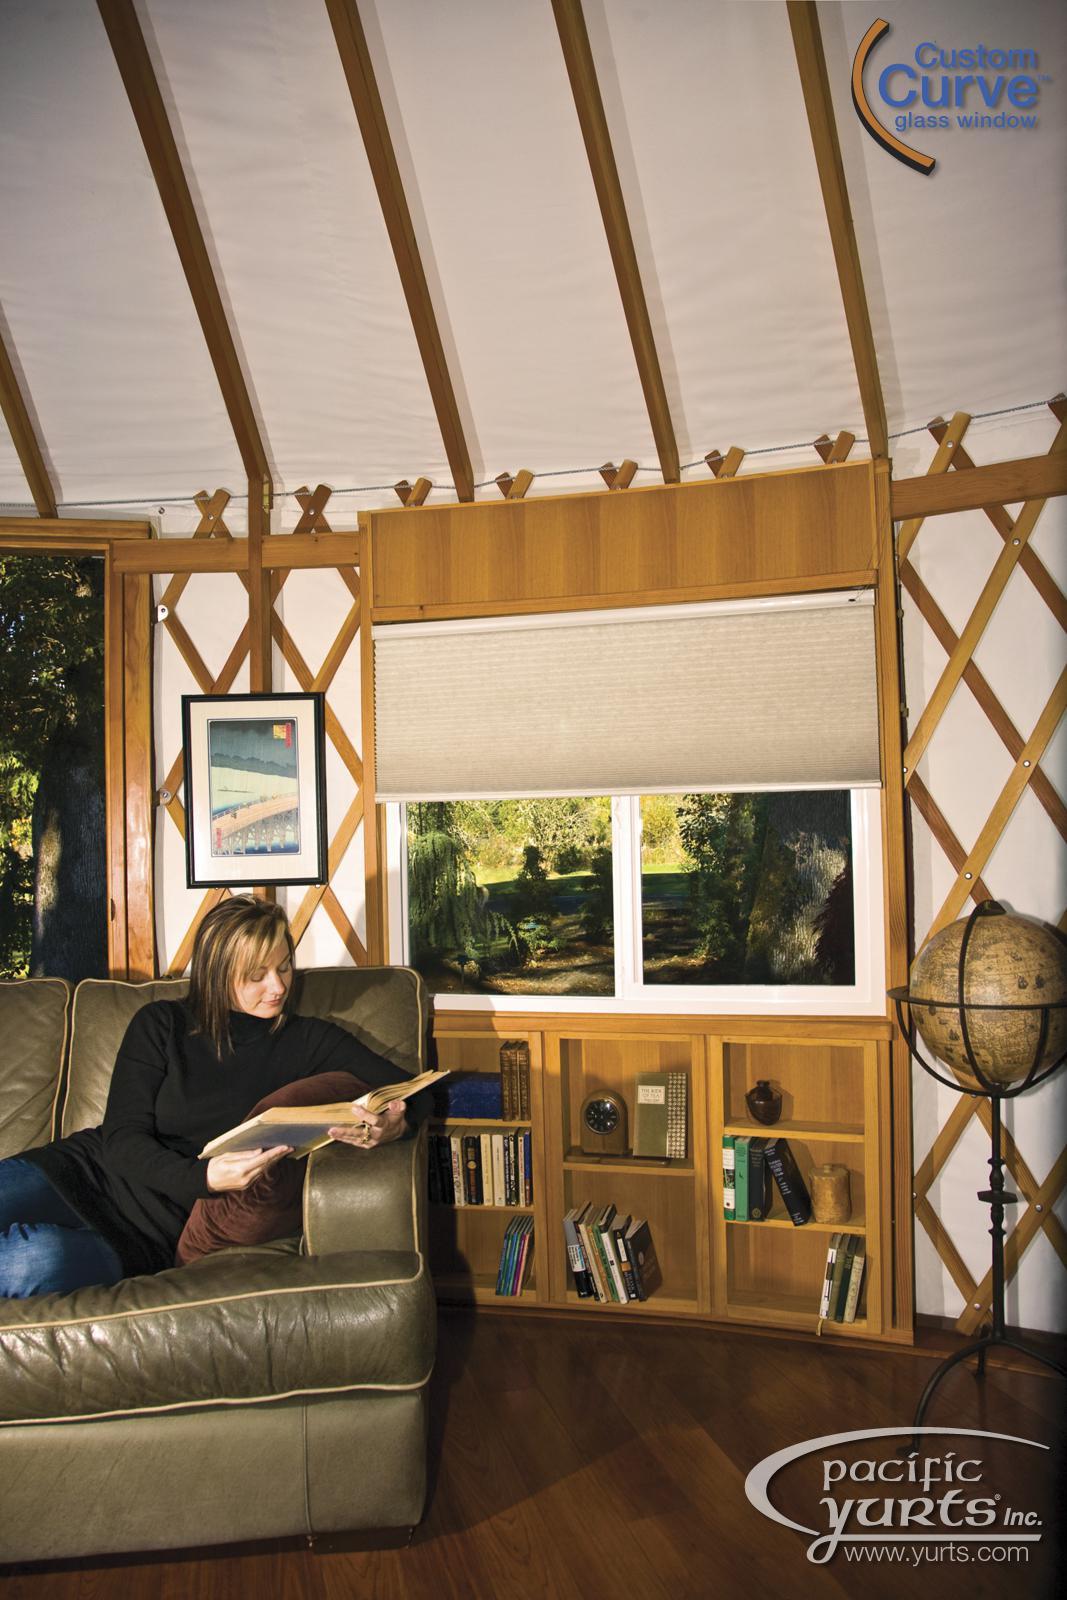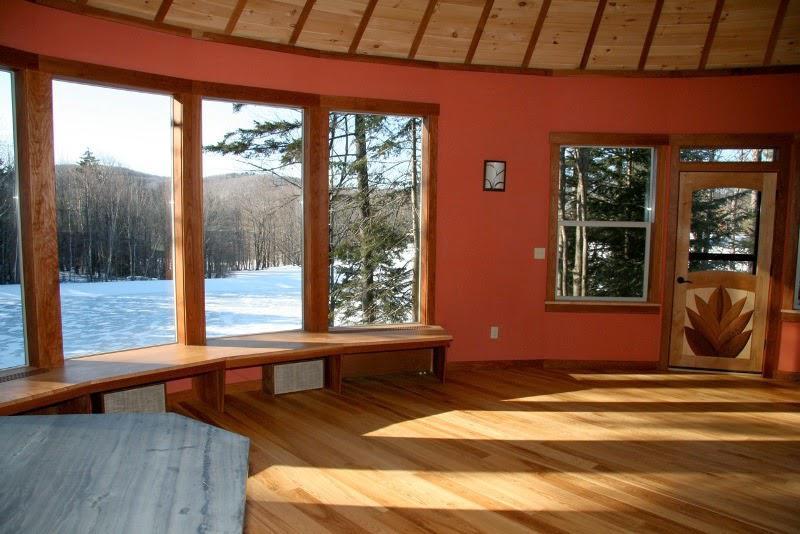The first image is the image on the left, the second image is the image on the right. Evaluate the accuracy of this statement regarding the images: "There is one fram on the wall in the image on the left". Is it true? Answer yes or no. Yes. 